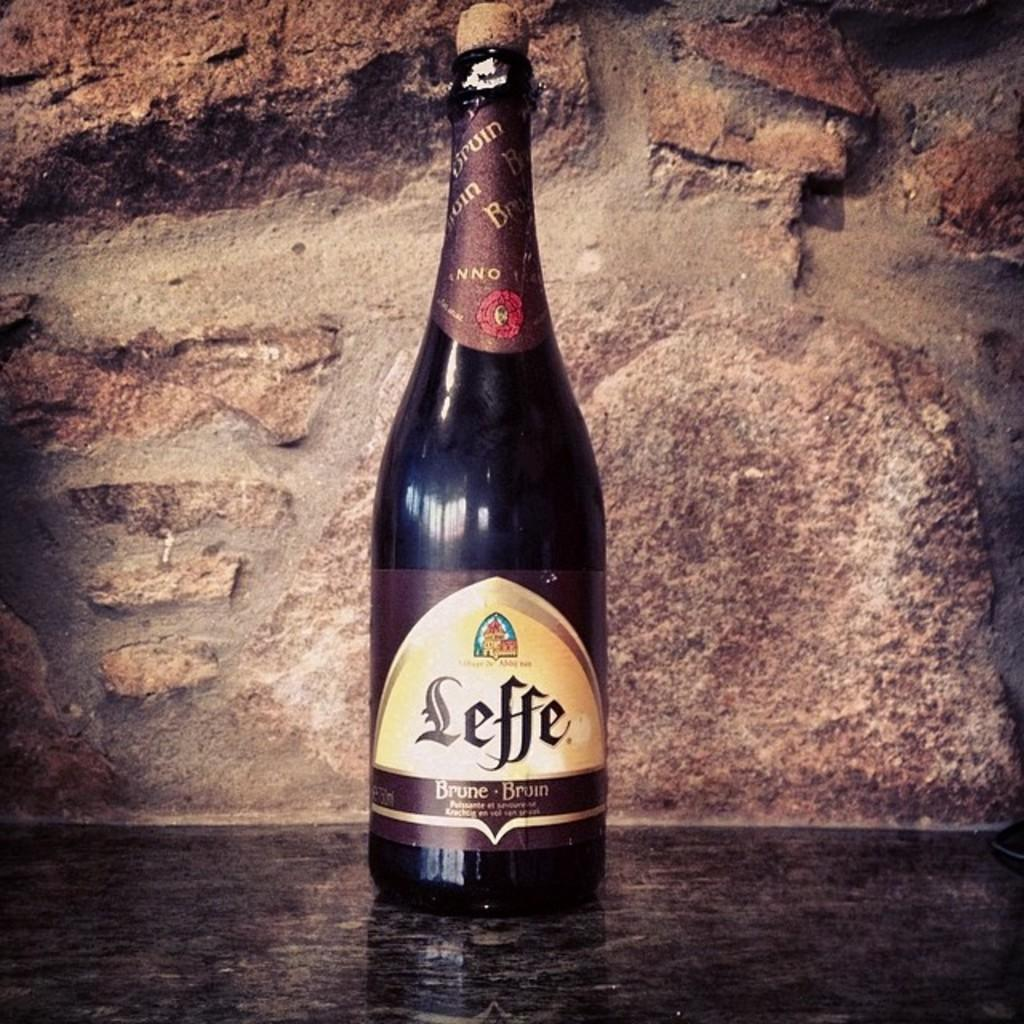<image>
Give a short and clear explanation of the subsequent image. A Leffe Brune Bruin bottle of liquor is displayed in front of a brown wall background 